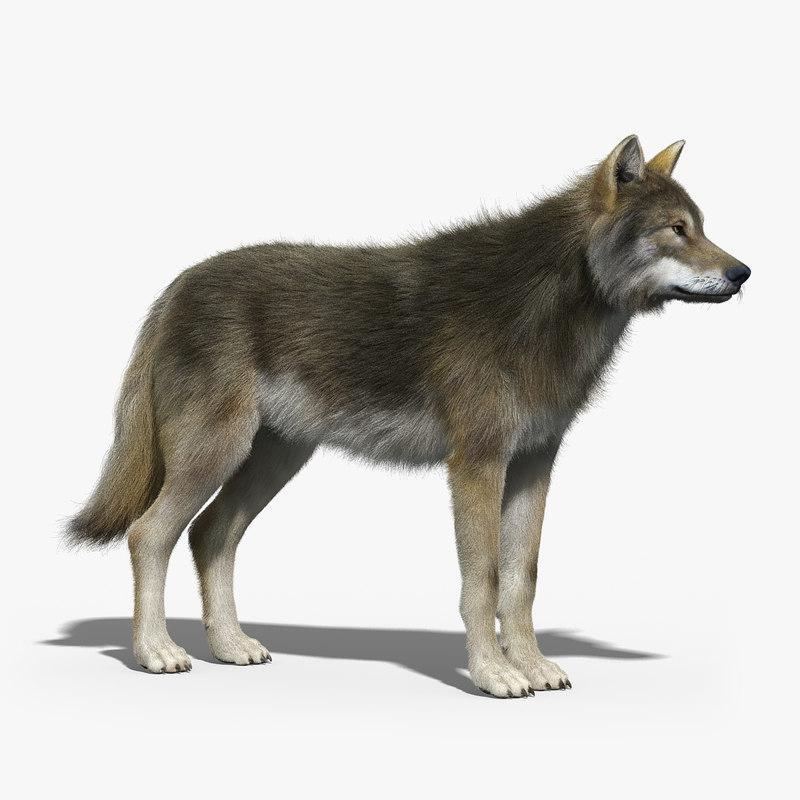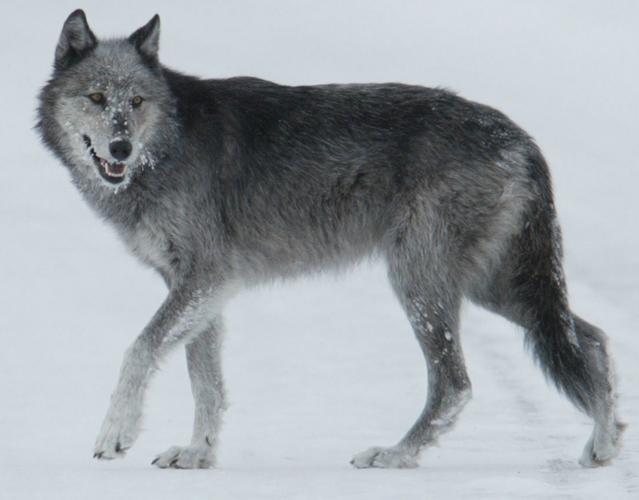The first image is the image on the left, the second image is the image on the right. Given the left and right images, does the statement "One image shows a howling wolf with raised head." hold true? Answer yes or no. No. 